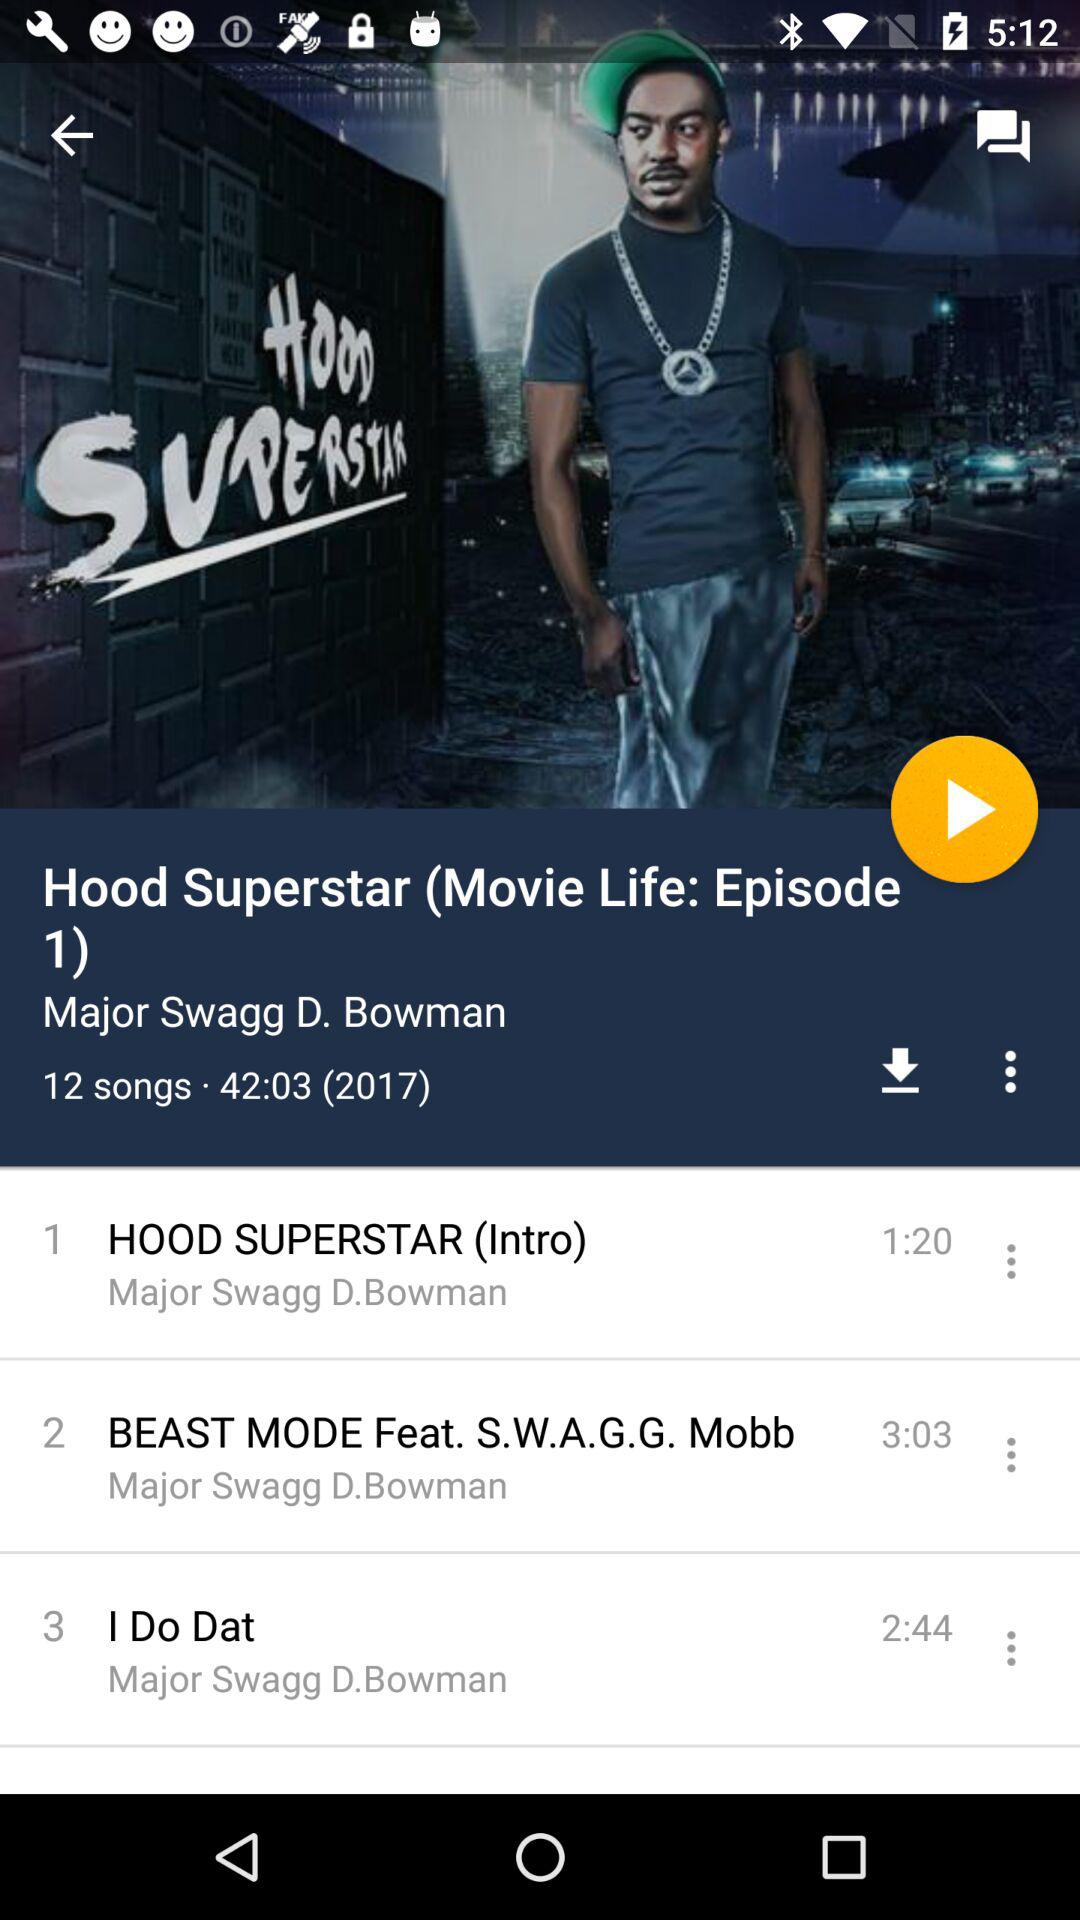What is the length of the song "I Do Dat"? The length of the song "I Do Dat" is 2 minutes 44 seconds. 